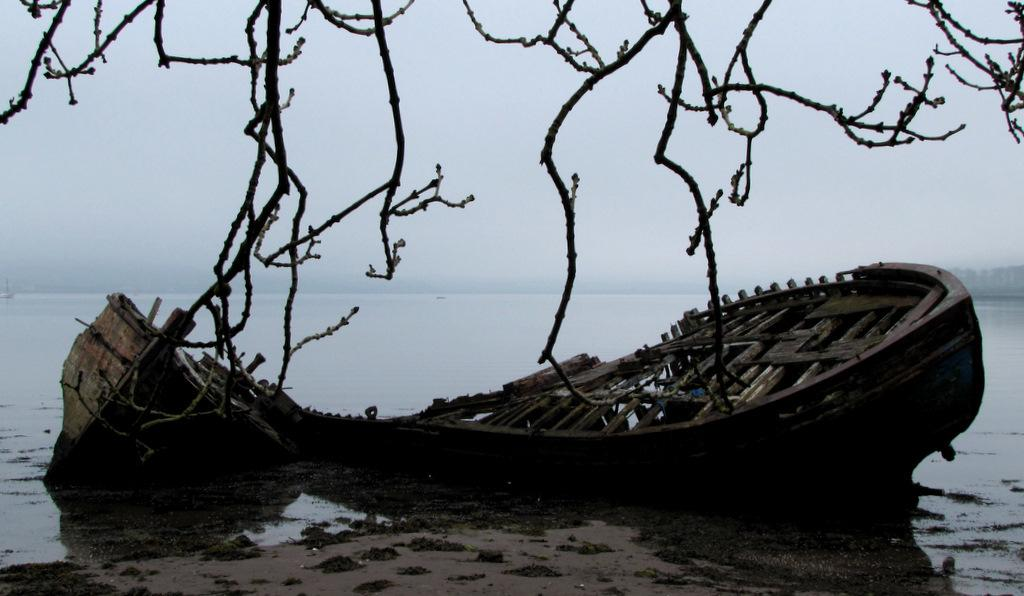What is the main subject of the image? The main subject of the image is a boat. Where is the boat located? The boat is on the water. What else can be seen in the image besides the boat? There are stems visible in the image. What is visible in the background of the image? The sky is visible in the background of the image. Where is the baby resting in the image? There is no baby present in the image. What type of tent can be seen in the image? There is no tent present in the image. 